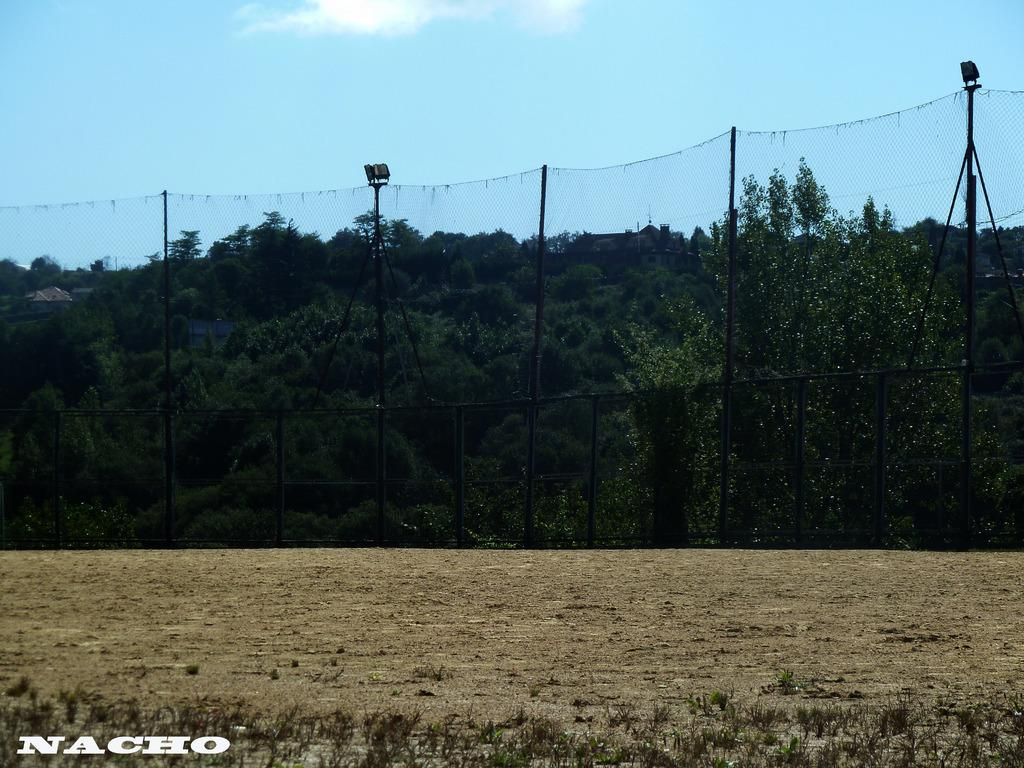What type of barrier is visible in the image? There is a closed mesh fence in the image. Are there any additional features on the fence? Yes, focus lights are present on top of the fence. What can be seen behind the fence? There are trees behind the fence. What information is provided at the bottom of the image? There is text at the bottom of the image. How many boys are playing with the care in the image? There are no boys or cars present in the image. What type of activity are the boys participating in with the care? There is no indication of any boys or cars in the image, so it is not possible to answer this question. 